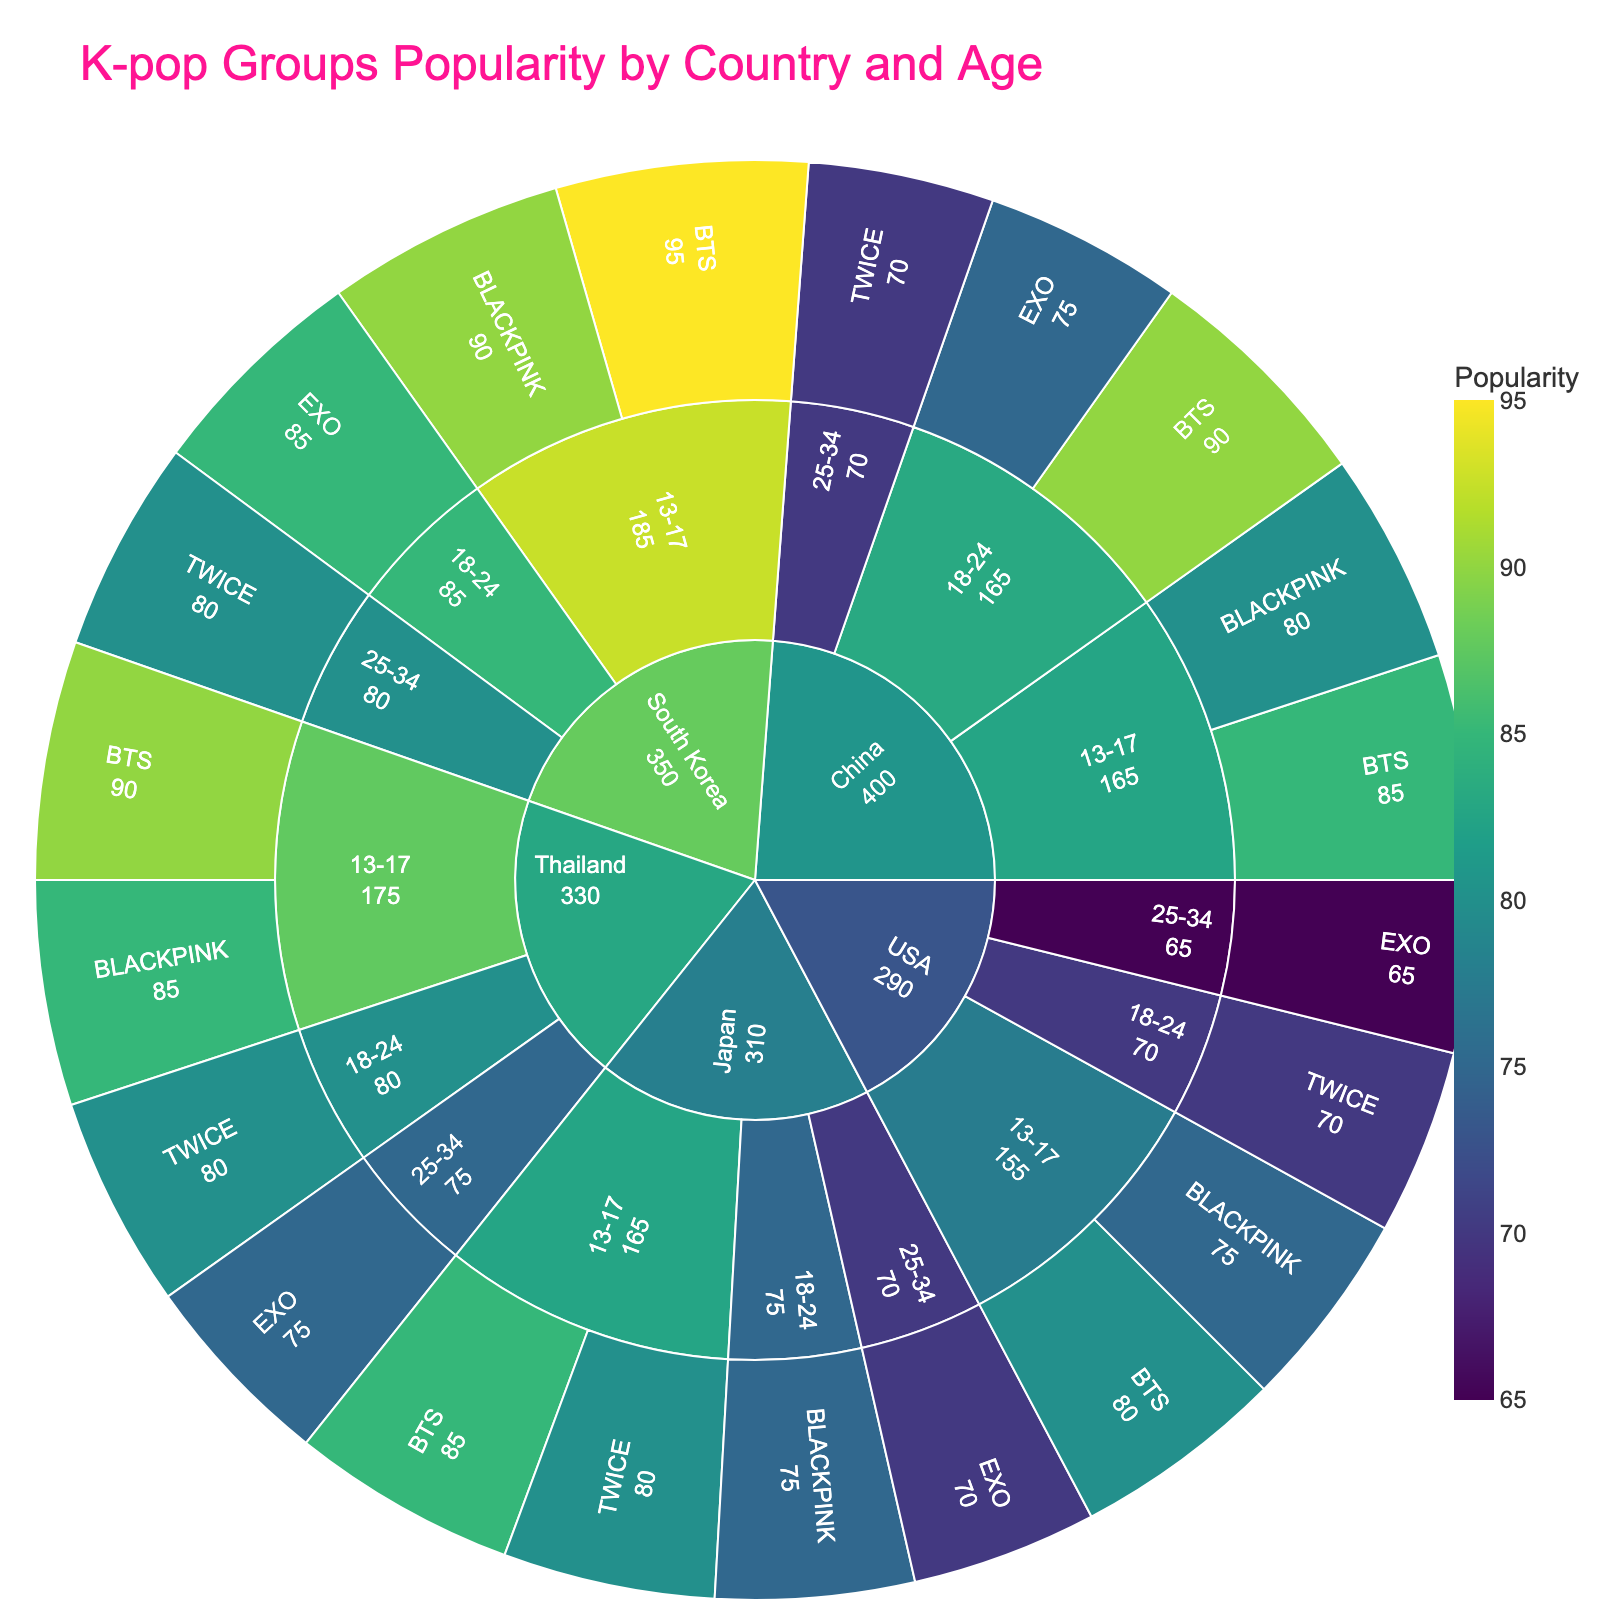What's the most popular K-pop group in China for the 18-24 age group? In the sunburst plot, locate China and then the 18-24 age group. The BTS segment is larger and has a higher popularity value than EXO, indicating BTS is more popular.
Answer: BTS Which country shows the highest popularity value for BTS in the 13-17 age group? Find the BTS segments within the 13-17 age group for each country. The segment for South Korea has the highest popularity value among all countries in this age group.
Answer: South Korea How does the popularity of BLACKPINK in Thailand's 13-17 age group compare to that of China's 13-17 age group? Locate the BLACKPINK segments for the 13-17 age group in Thailand and China. Compare the two values: Thailand's popularity value is higher than China's.
Answer: Thailand is higher What is the difference in popularity between TWICE in Japan's 25-34 age group and the USA's 25-34 age group? Identify TWICE segments in the 25-34 age group for both Japan and the USA. Subtract Japan's value (70) from the USA's value (not found).
Answer: 0, TWICE not found in USA 25-34 Which K-pop group has the highest popularity in South Korea across all age groups? Within the South Korea section, compare the popularity figures for each age group and their respective K-pop groups. BTS has the highest value in the 13-17 age group.
Answer: BTS How many age groups in China have BTS as the most popular K-pop group? In the China's section, count the age groups where BTS has the highest popularity value. Both 13-17 and 18-24 age groups have BTS as the most popular.
Answer: 2 What's the overall trend in popularity for EXO across different age groups in Thailand? Look at EXO segments for all age groups in Thailand. Notice the values are consistent but not the highest in any group.
Answer: Consistent, but not highest in any group Which country shows the least popularity for BTS in the 13-17 age group? Compare the BTS segments within the 13-17 age group for every country. The USA has the lowest popularity value in this group.
Answer: USA Is TWICE or BLACKPINK more popular among the 13-17 age group in Japan? Compare the values of TWICE and BLACKPINK within the 13-17 age group in Japan. TWICE has a higher value than BLACKPINK.
Answer: TWICE 